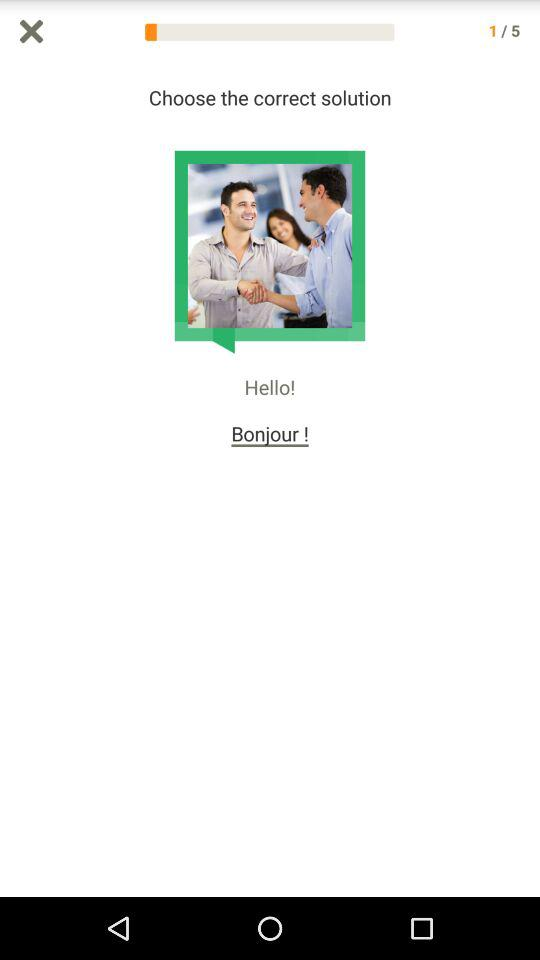Which are the different reasons? The different reasons are "Language/cultural interest", "Travel", "For family/friends", "School", "Work", "To train my language skills" and "Other". 